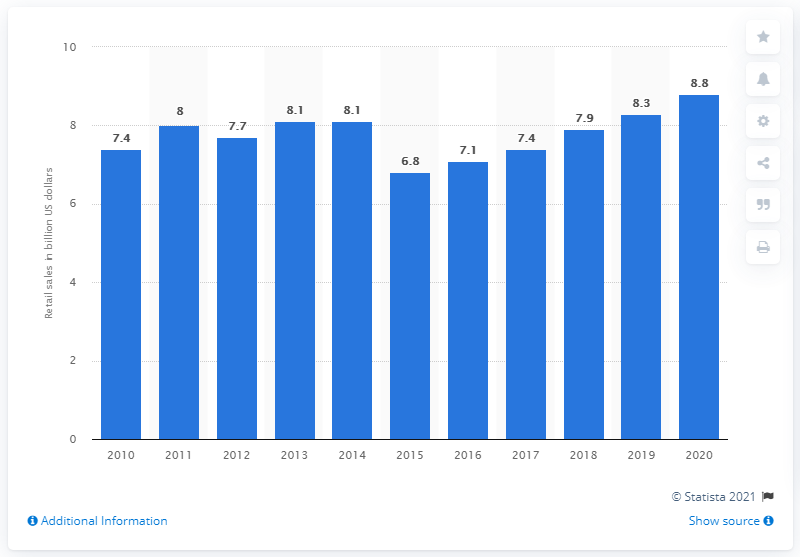Mention a couple of crucial points in this snapshot. It is projected that the retail sales of herbal and traditional products will increase in the year 2020. The retail sales of herbal and traditional products are projected to increase to 8.8 in 2020. In 2010, the retail sales of herbal and traditional products were 7.4 billion dollars. 